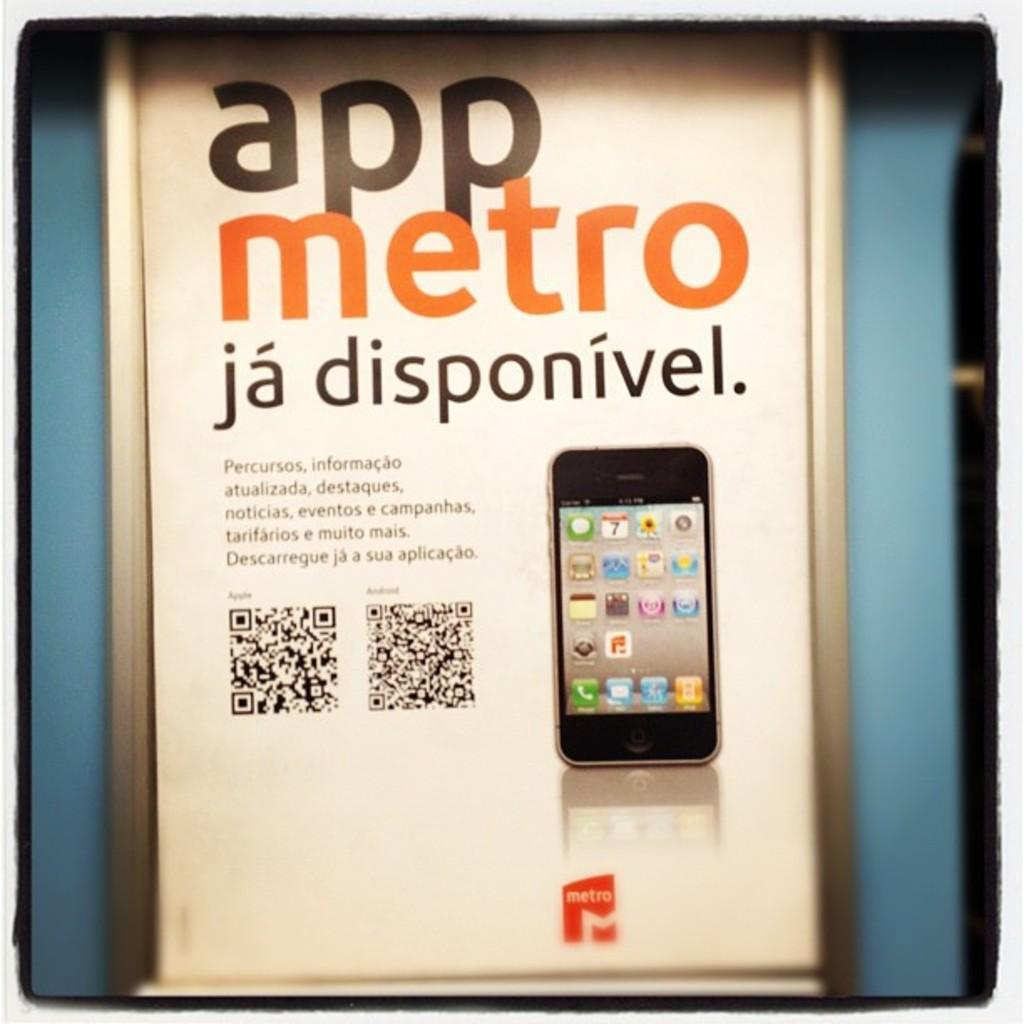<image>
Offer a succinct explanation of the picture presented. the app metro that has a phone on it 